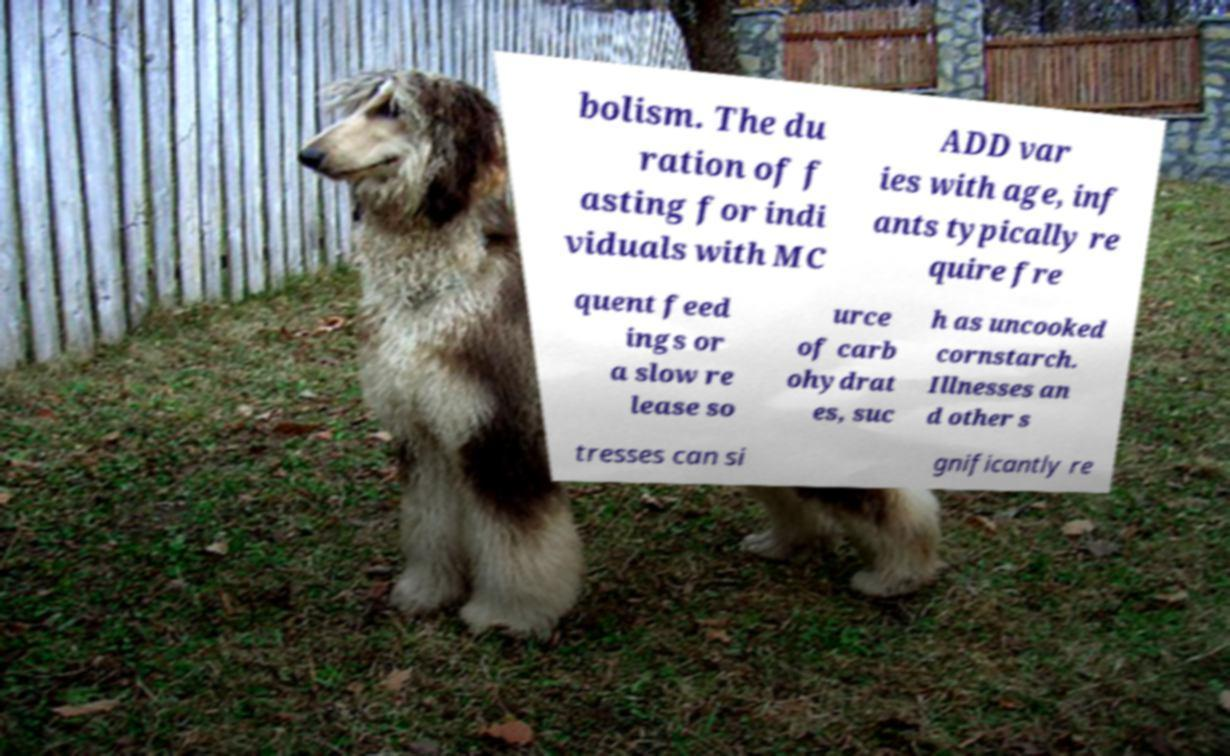What messages or text are displayed in this image? I need them in a readable, typed format. bolism. The du ration of f asting for indi viduals with MC ADD var ies with age, inf ants typically re quire fre quent feed ings or a slow re lease so urce of carb ohydrat es, suc h as uncooked cornstarch. Illnesses an d other s tresses can si gnificantly re 